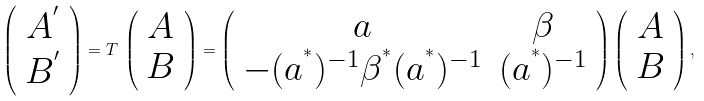<formula> <loc_0><loc_0><loc_500><loc_500>\left ( \begin{array} { c } A ^ { ^ { \prime } } \\ B ^ { ^ { \prime } } \end{array} \right ) = T \, \left ( \begin{array} { c } A \\ B \end{array} \right ) = \left ( \begin{array} { c c } a & \beta \\ - ( a ^ { ^ { * } } ) ^ { - 1 } \beta ^ { ^ { * } } ( a ^ { ^ { * } } ) ^ { - 1 } & ( a ^ { ^ { * } } ) ^ { - 1 } \end{array} \right ) \left ( \begin{array} { c } A \\ B \end{array} \right ) ,</formula> 